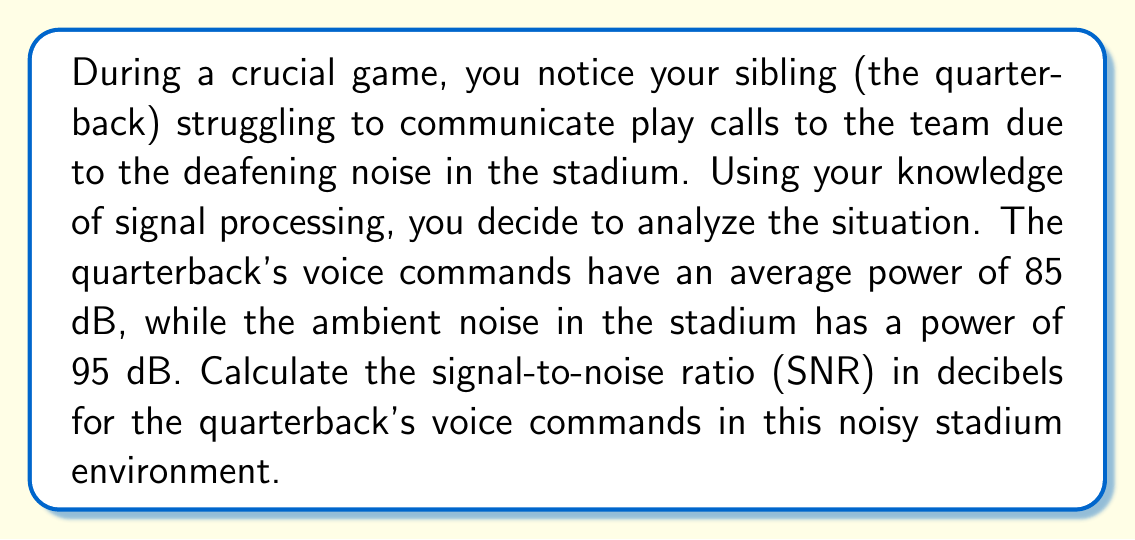Teach me how to tackle this problem. To solve this problem, we need to follow these steps:

1) First, recall the formula for Signal-to-Noise Ratio (SNR) in decibels:

   $$ SNR_{dB} = 10 \log_{10}\left(\frac{P_{signal}}{P_{noise}}\right) $$

   Where $P_{signal}$ is the power of the signal (quarterback's voice) and $P_{noise}$ is the power of the noise (stadium ambient noise).

2) We are given the power levels in decibels, but we need to convert these to linear power ratios. The formula to convert from decibels to power ratio is:

   $$ P = 10^{\frac{dB}{10}} $$

3) For the quarterback's voice (signal):
   $$ P_{signal} = 10^{\frac{85}{10}} = 10^{8.5} = 3.16 \times 10^8 $$

4) For the stadium noise:
   $$ P_{noise} = 10^{\frac{95}{10}} = 10^{9.5} = 3.16 \times 10^9 $$

5) Now we can plug these values into our SNR formula:

   $$ SNR_{dB} = 10 \log_{10}\left(\frac{3.16 \times 10^8}{3.16 \times 10^9}\right) $$

6) Simplify:
   $$ SNR_{dB} = 10 \log_{10}\left(\frac{1}{10}\right) = 10 \log_{10}(0.1) $$

7) Calculate:
   $$ SNR_{dB} = 10 \times (-1) = -10 $$

Therefore, the Signal-to-Noise Ratio is -10 dB.
Answer: -10 dB 